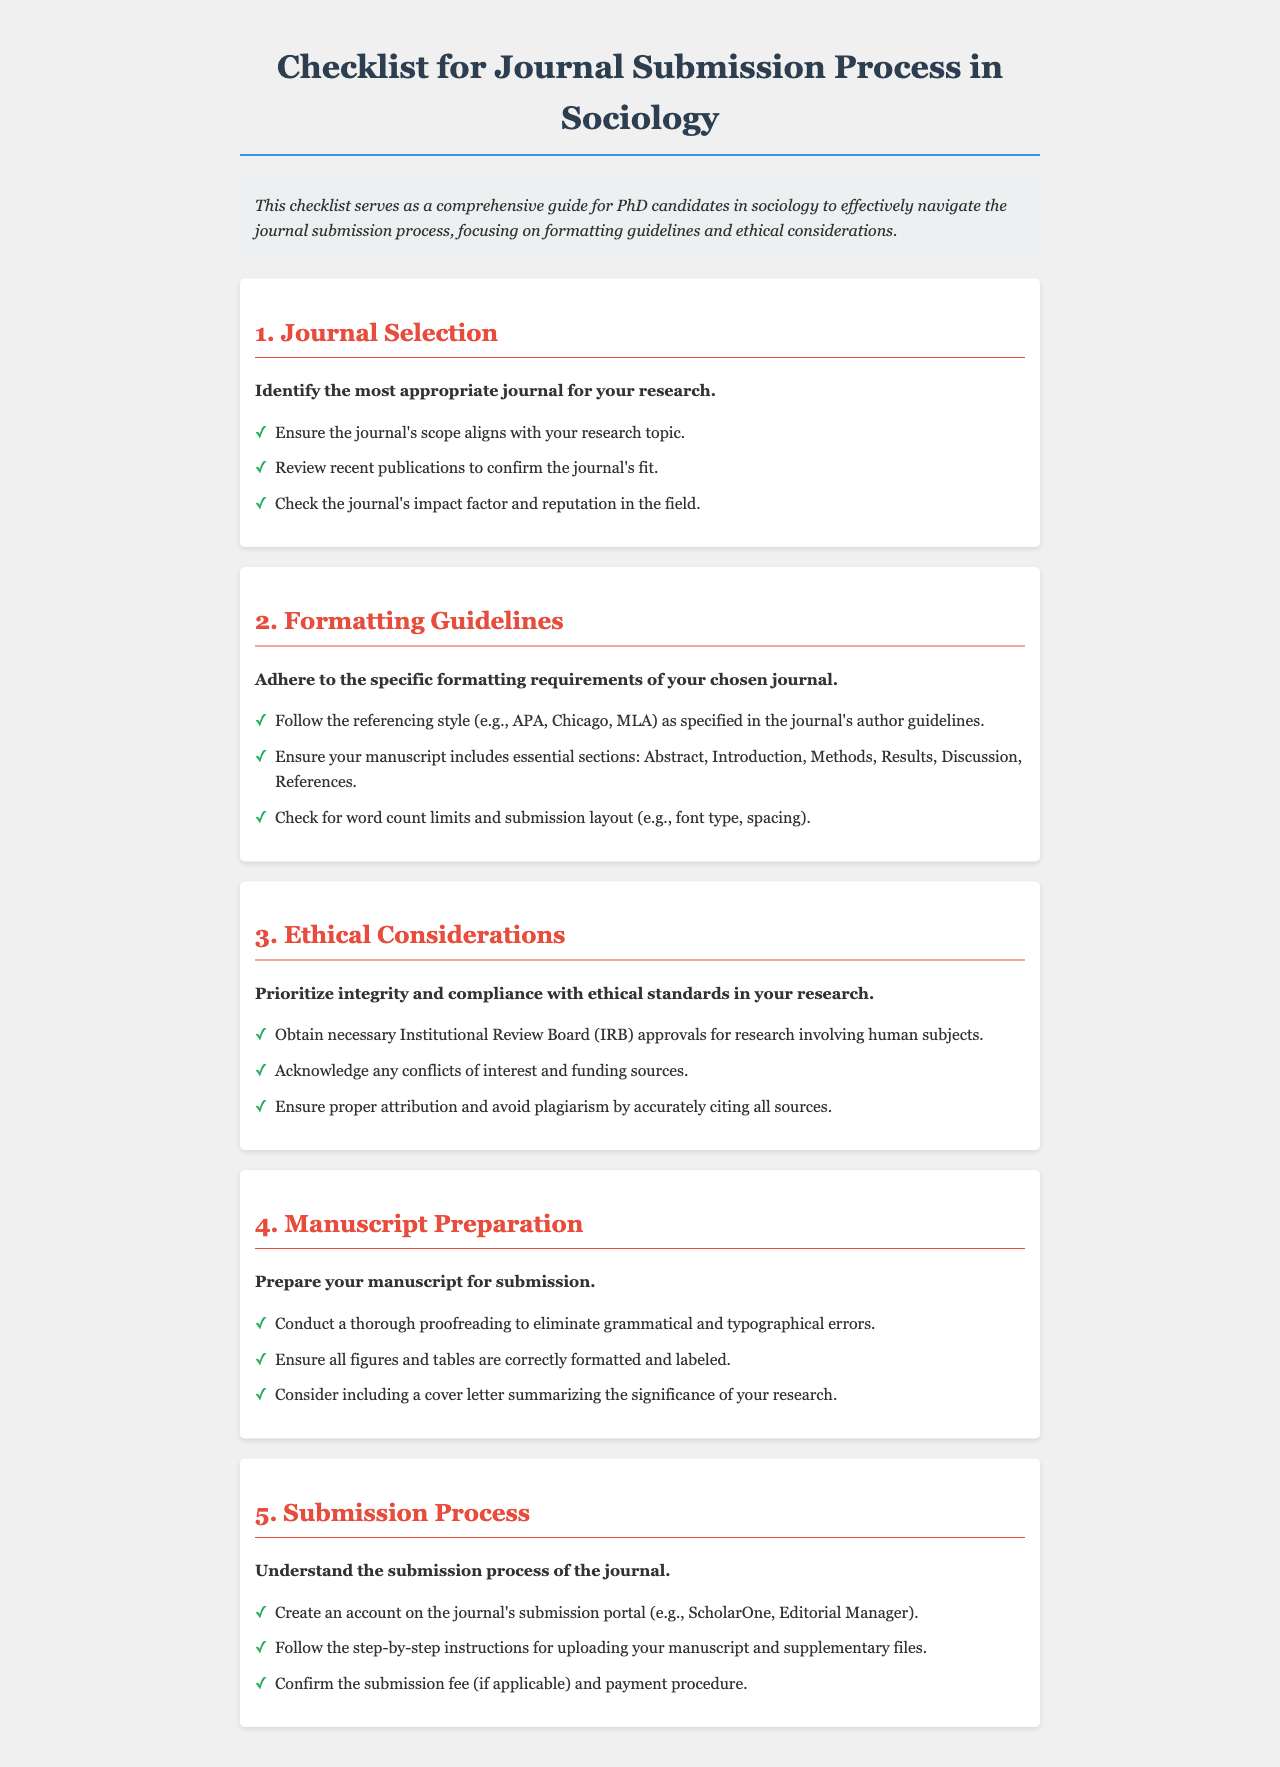What is the title of the document? The title is presented at the top of the document in a prominent format, stating the purpose of the checklist.
Answer: Checklist for Journal Submission Process in Sociology What is the first section of the checklist? The sections are numbered and titled, making it easy to identify the first category covered in the checklist.
Answer: Journal Selection How many essential sections should be included in the manuscript? The document specifically lists the required sections that should be part of a manuscript submission.
Answer: Six What must be obtained for research involving human subjects? This requirement is mentioned clearly in the ethical considerations section of the document.
Answer: Institutional Review Board approvals What should be included in a cover letter? The document suggests an element that could be featured in the cover letter when submitting a manuscript.
Answer: Significance of your research Which submission portals are mentioned? The document refers to specific platforms commonly used for journal submissions in the sociological field.
Answer: ScholarOne, Editorial Manager 